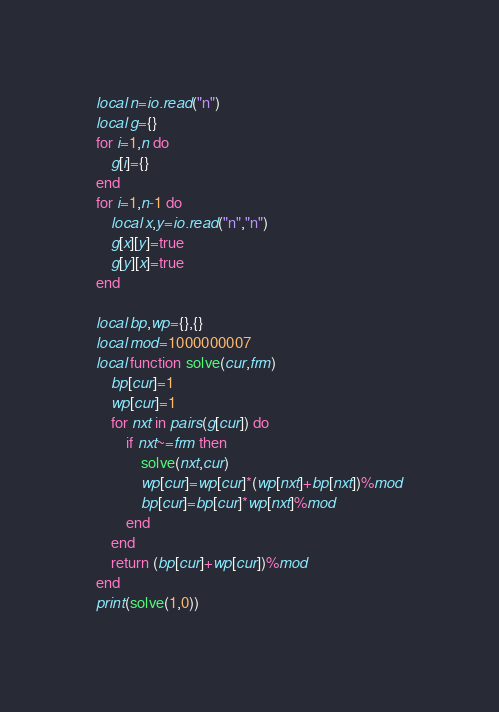<code> <loc_0><loc_0><loc_500><loc_500><_Lua_>local n=io.read("n")
local g={}
for i=1,n do
    g[i]={}
end
for i=1,n-1 do
    local x,y=io.read("n","n")
    g[x][y]=true
    g[y][x]=true
end

local bp,wp={},{}
local mod=1000000007
local function solve(cur,frm)
    bp[cur]=1
    wp[cur]=1
    for nxt in pairs(g[cur]) do
        if nxt~=frm then
            solve(nxt,cur)
            wp[cur]=wp[cur]*(wp[nxt]+bp[nxt])%mod
            bp[cur]=bp[cur]*wp[nxt]%mod
        end
    end
    return (bp[cur]+wp[cur])%mod
end
print(solve(1,0))</code> 